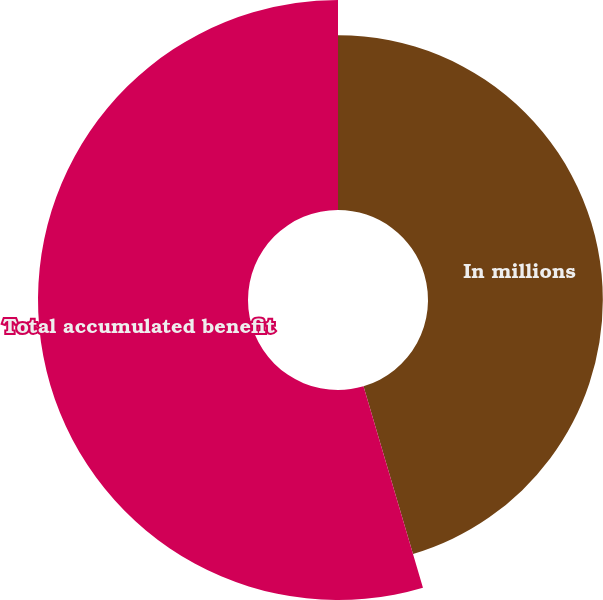Convert chart to OTSL. <chart><loc_0><loc_0><loc_500><loc_500><pie_chart><fcel>In millions<fcel>Total accumulated benefit<nl><fcel>45.43%<fcel>54.57%<nl></chart> 